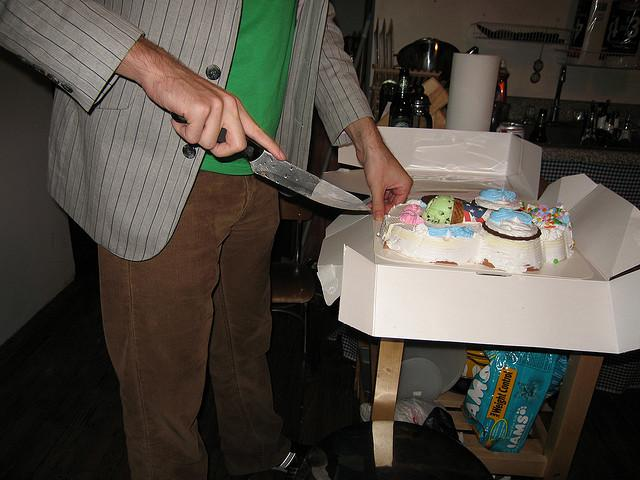What might be a major component of this treat? ice cream 